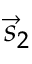<formula> <loc_0><loc_0><loc_500><loc_500>\vec { s } _ { 2 }</formula> 